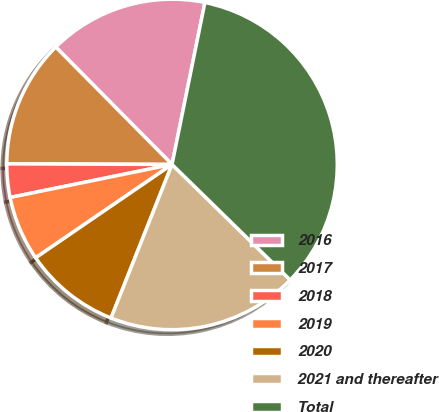Convert chart. <chart><loc_0><loc_0><loc_500><loc_500><pie_chart><fcel>2016<fcel>2017<fcel>2018<fcel>2019<fcel>2020<fcel>2021 and thereafter<fcel>Total<nl><fcel>15.61%<fcel>12.52%<fcel>3.26%<fcel>6.35%<fcel>9.43%<fcel>18.7%<fcel>34.13%<nl></chart> 